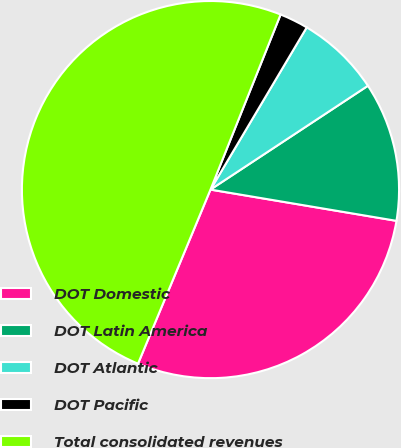Convert chart to OTSL. <chart><loc_0><loc_0><loc_500><loc_500><pie_chart><fcel>DOT Domestic<fcel>DOT Latin America<fcel>DOT Atlantic<fcel>DOT Pacific<fcel>Total consolidated revenues<nl><fcel>28.63%<fcel>11.93%<fcel>7.2%<fcel>2.46%<fcel>49.79%<nl></chart> 